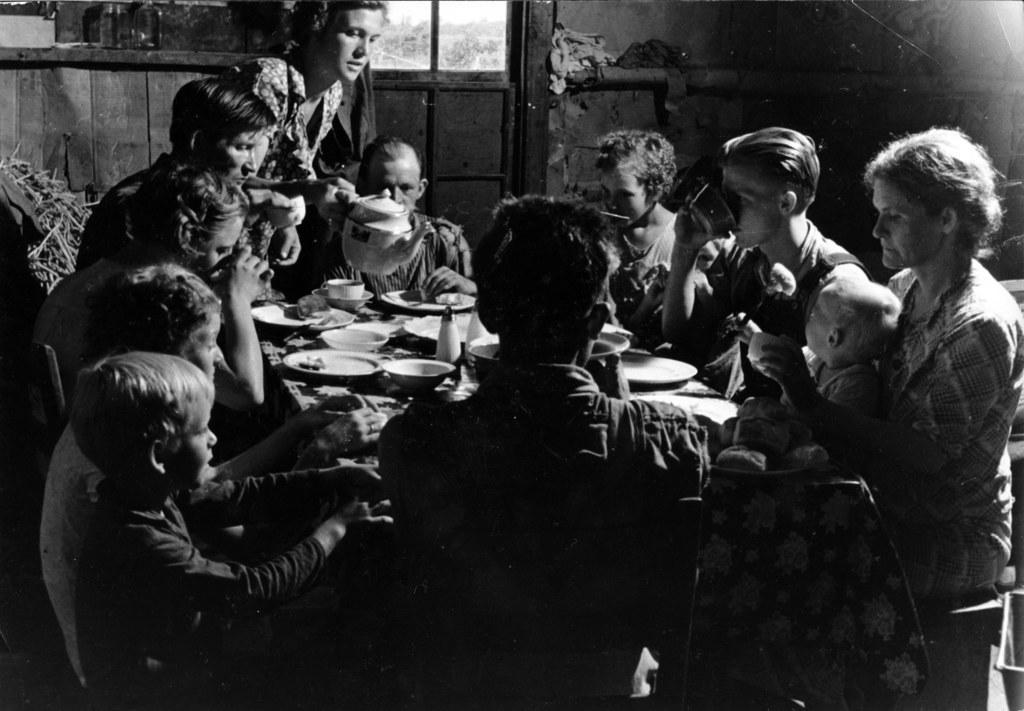How would you summarize this image in a sentence or two? This is a black and white image. In this image we can see group of persons sitting around the table. On the table we can see plates, food, cup and saucer. In the background we can see door and wall. 